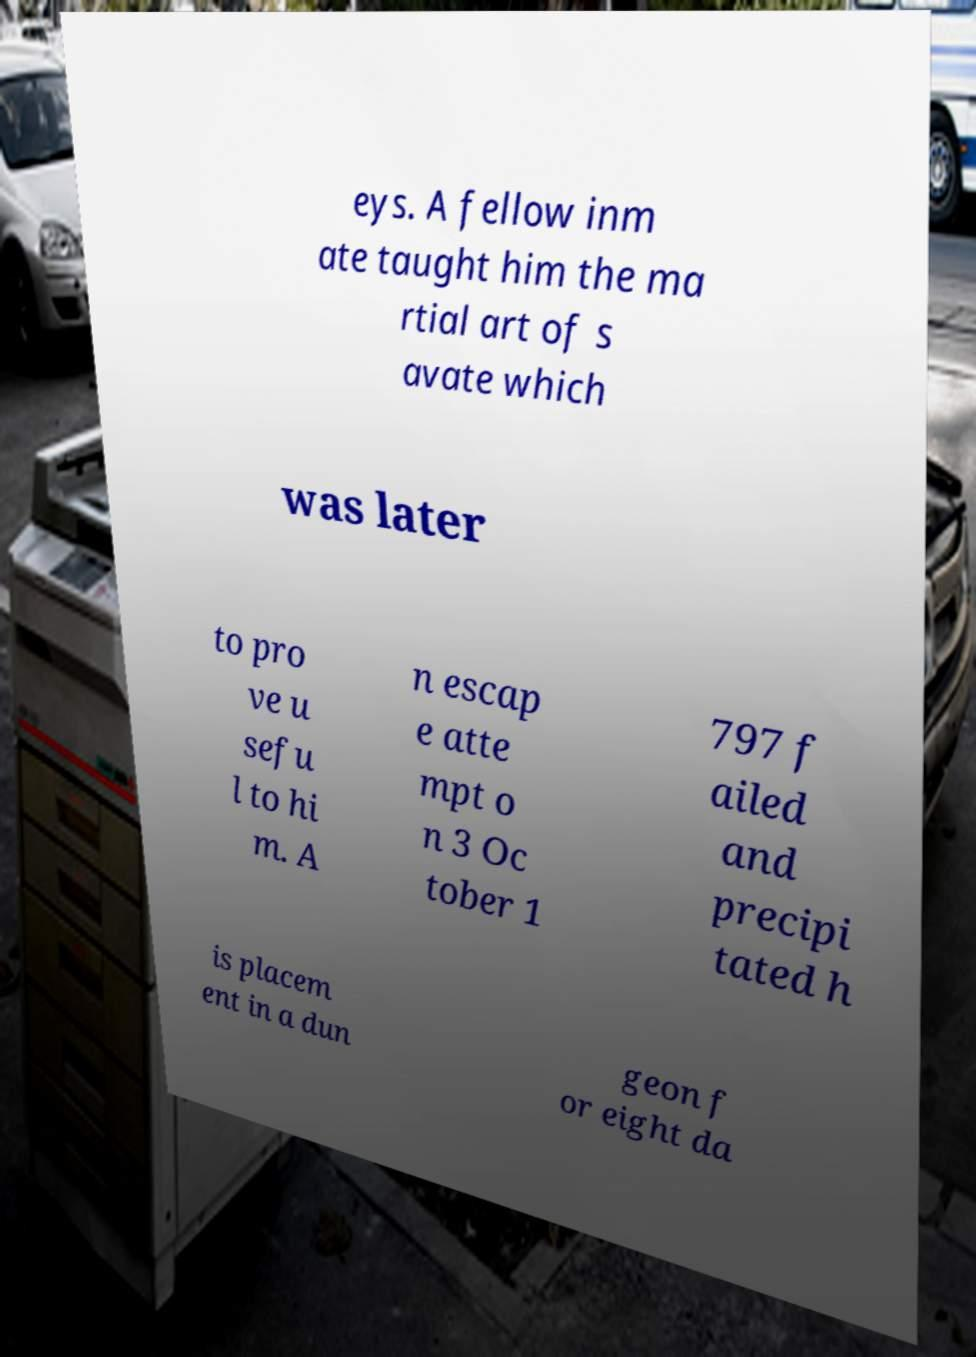For documentation purposes, I need the text within this image transcribed. Could you provide that? eys. A fellow inm ate taught him the ma rtial art of s avate which was later to pro ve u sefu l to hi m. A n escap e atte mpt o n 3 Oc tober 1 797 f ailed and precipi tated h is placem ent in a dun geon f or eight da 